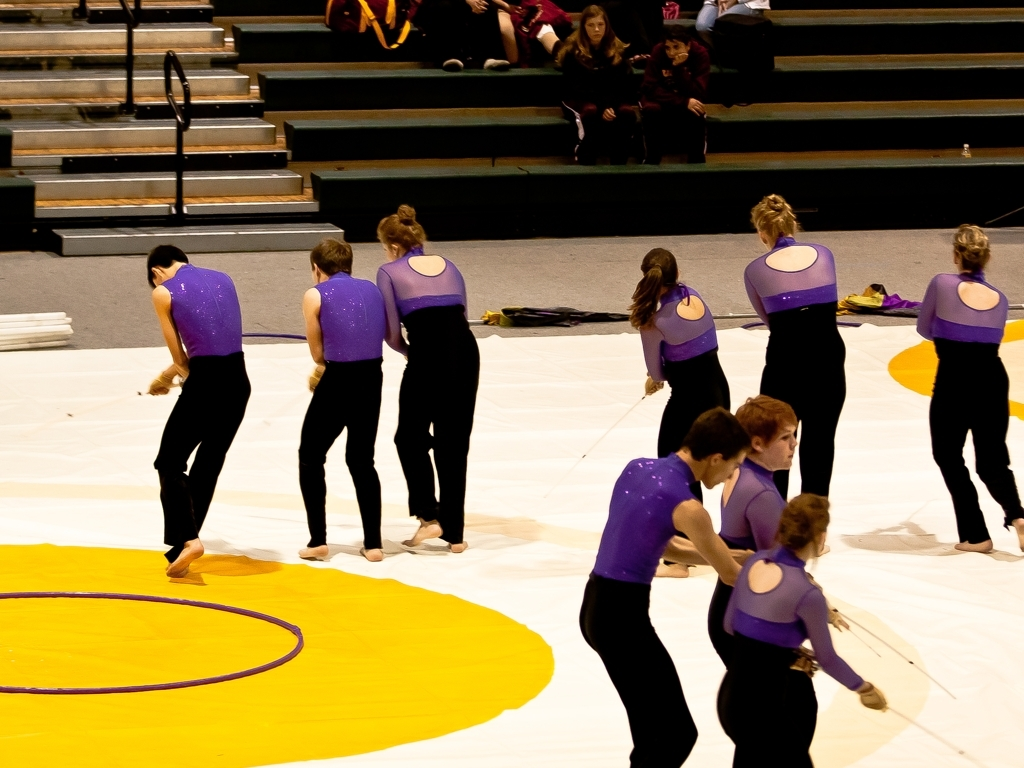How do the performers seem to be feeling based on their body language? The performers exhibit focused and deliberate body language which, along with their facial expressions, may indicate concentration and commitment to their routine. This body language contributes to the overall impression of a serious performance rather than a casual display. Could you speculate on the type of audience this performance is aimed at? Given the formal setting and the organized seating, the performance is likely aimed at an audience that appreciates staged events such as dance recitals, gymnastic demonstrations, or color guard routines. The presence of an audience in tiered seating also suggests it could be part of a larger event or competition. 